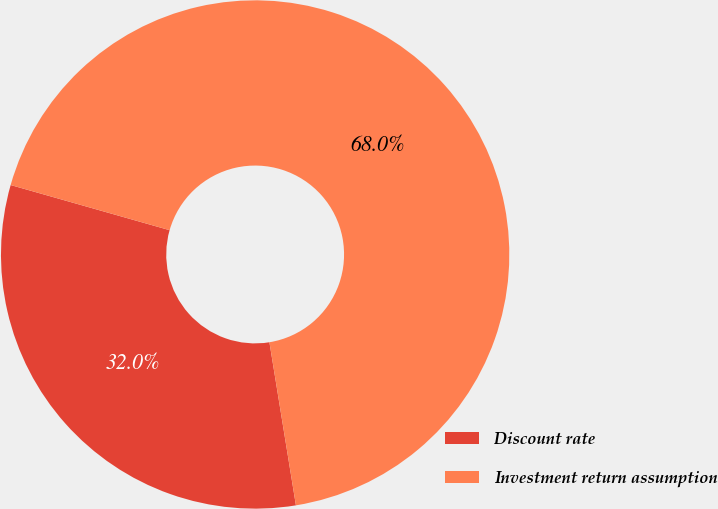Convert chart. <chart><loc_0><loc_0><loc_500><loc_500><pie_chart><fcel>Discount rate<fcel>Investment return assumption<nl><fcel>31.97%<fcel>68.03%<nl></chart> 